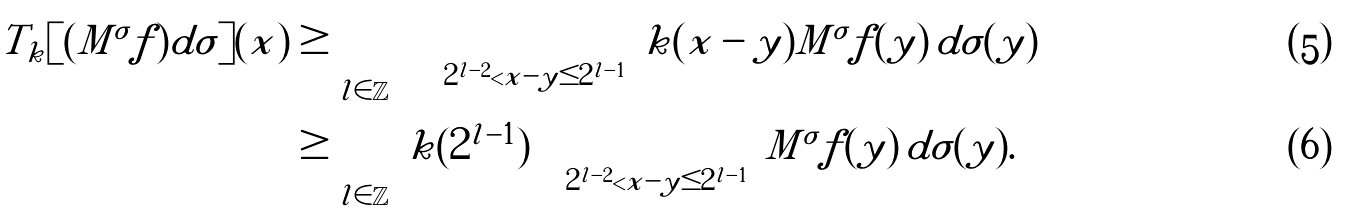<formula> <loc_0><loc_0><loc_500><loc_500>T _ { k } [ ( M ^ { \sigma } f ) d \sigma ] ( x ) & \geq \sum _ { l \in \mathbb { Z } } \, \int _ { 2 ^ { l - 2 } < | x - y | \leq 2 ^ { l - 1 } } k ( x - y ) M ^ { \sigma } f ( y ) \, d \sigma ( y ) \\ & \geq \sum _ { l \in \mathbb { Z } } \, k ( 2 ^ { l - 1 } ) \int _ { 2 ^ { l - 2 } < | x - y | \leq 2 ^ { l - 1 } } M ^ { \sigma } f ( y ) \, d \sigma ( y ) .</formula> 